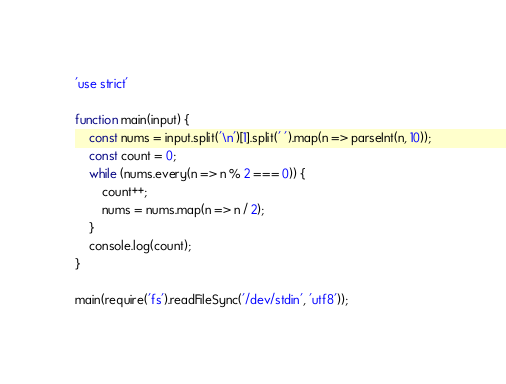Convert code to text. <code><loc_0><loc_0><loc_500><loc_500><_JavaScript_>'use strict'

function main(input) {
    const nums = input.split('\n')[1].split(' ').map(n => parseInt(n, 10));
    const count = 0;
    while (nums.every(n => n % 2 === 0)) {
        count++;
        nums = nums.map(n => n / 2);
    }
    console.log(count);
}
 
main(require('fs').readFileSync('/dev/stdin', 'utf8'));</code> 